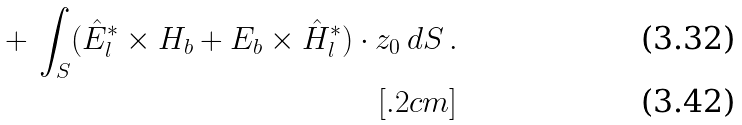<formula> <loc_0><loc_0><loc_500><loc_500>+ \, \int _ { S } ( \hat { E } _ { l } ^ { * } \times { H } _ { b } + { E } _ { b } \times \hat { H } _ { l } ^ { * } ) \cdot { z } _ { 0 } \, d S \, . \\ [ . 2 c m ]</formula> 